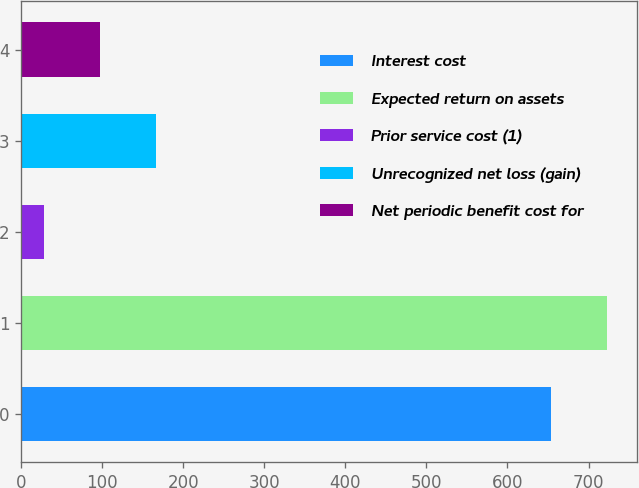Convert chart. <chart><loc_0><loc_0><loc_500><loc_500><bar_chart><fcel>Interest cost<fcel>Expected return on assets<fcel>Prior service cost (1)<fcel>Unrecognized net loss (gain)<fcel>Net periodic benefit cost for<nl><fcel>654<fcel>723.2<fcel>28<fcel>166.4<fcel>97.2<nl></chart> 